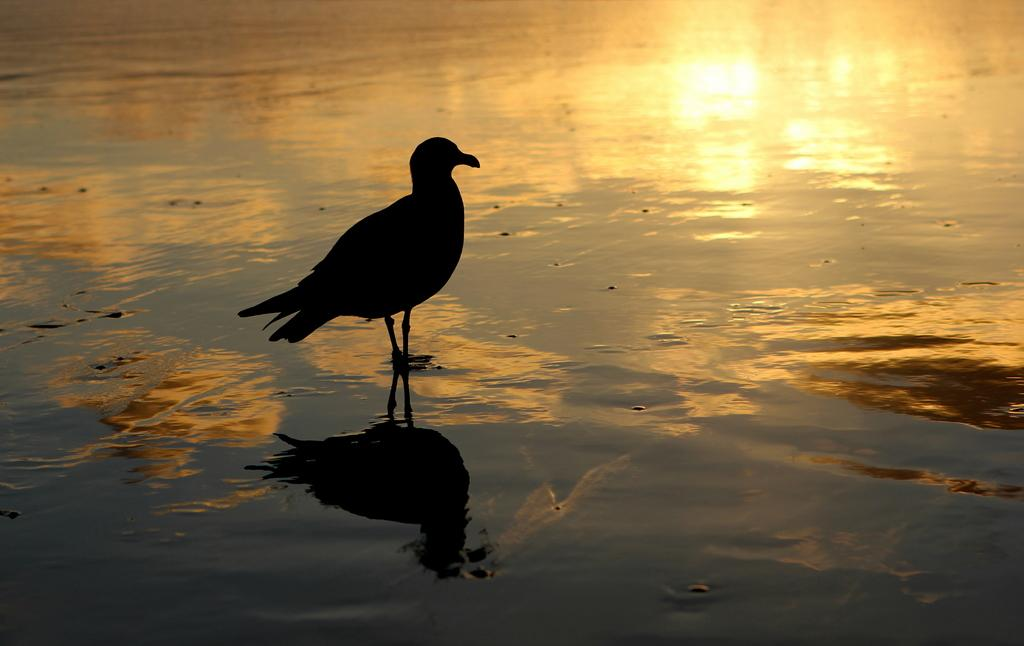Where was the picture taken? The picture was clicked outside. What can be seen in the foreground of the image? There is a water body in the foreground of the image. What is present in the water body? There is a bird standing in the water body. What else can be seen in the image? There are other items visible in the image. What is the aftermath of the copy machine malfunction in the image? There is no copy machine or any indication of a malfunction in the image. 